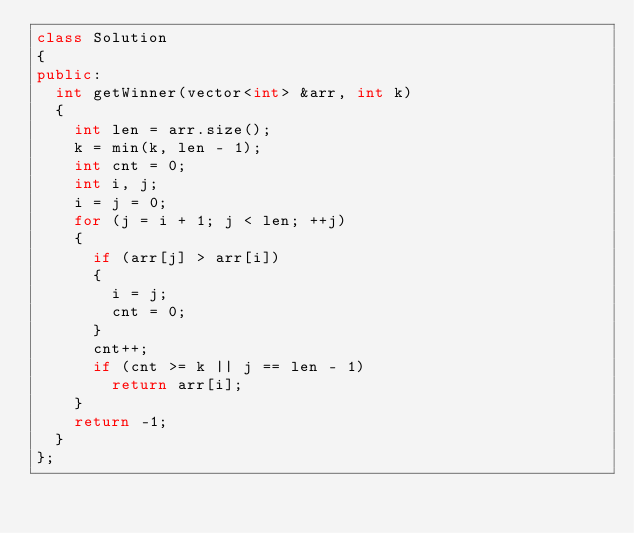Convert code to text. <code><loc_0><loc_0><loc_500><loc_500><_C++_>class Solution
{
public:
  int getWinner(vector<int> &arr, int k)
  {
    int len = arr.size();
    k = min(k, len - 1);
    int cnt = 0;
    int i, j;
    i = j = 0;
    for (j = i + 1; j < len; ++j)
    {
      if (arr[j] > arr[i])
      {
        i = j;
        cnt = 0;
      }
      cnt++;
      if (cnt >= k || j == len - 1)
        return arr[i];
    }
    return -1;
  }
};</code> 